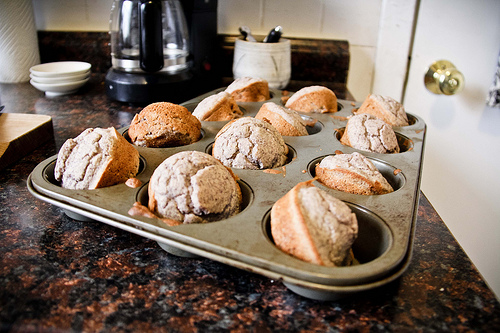<image>
Is there a cup on the tray? No. The cup is not positioned on the tray. They may be near each other, but the cup is not supported by or resting on top of the tray. 